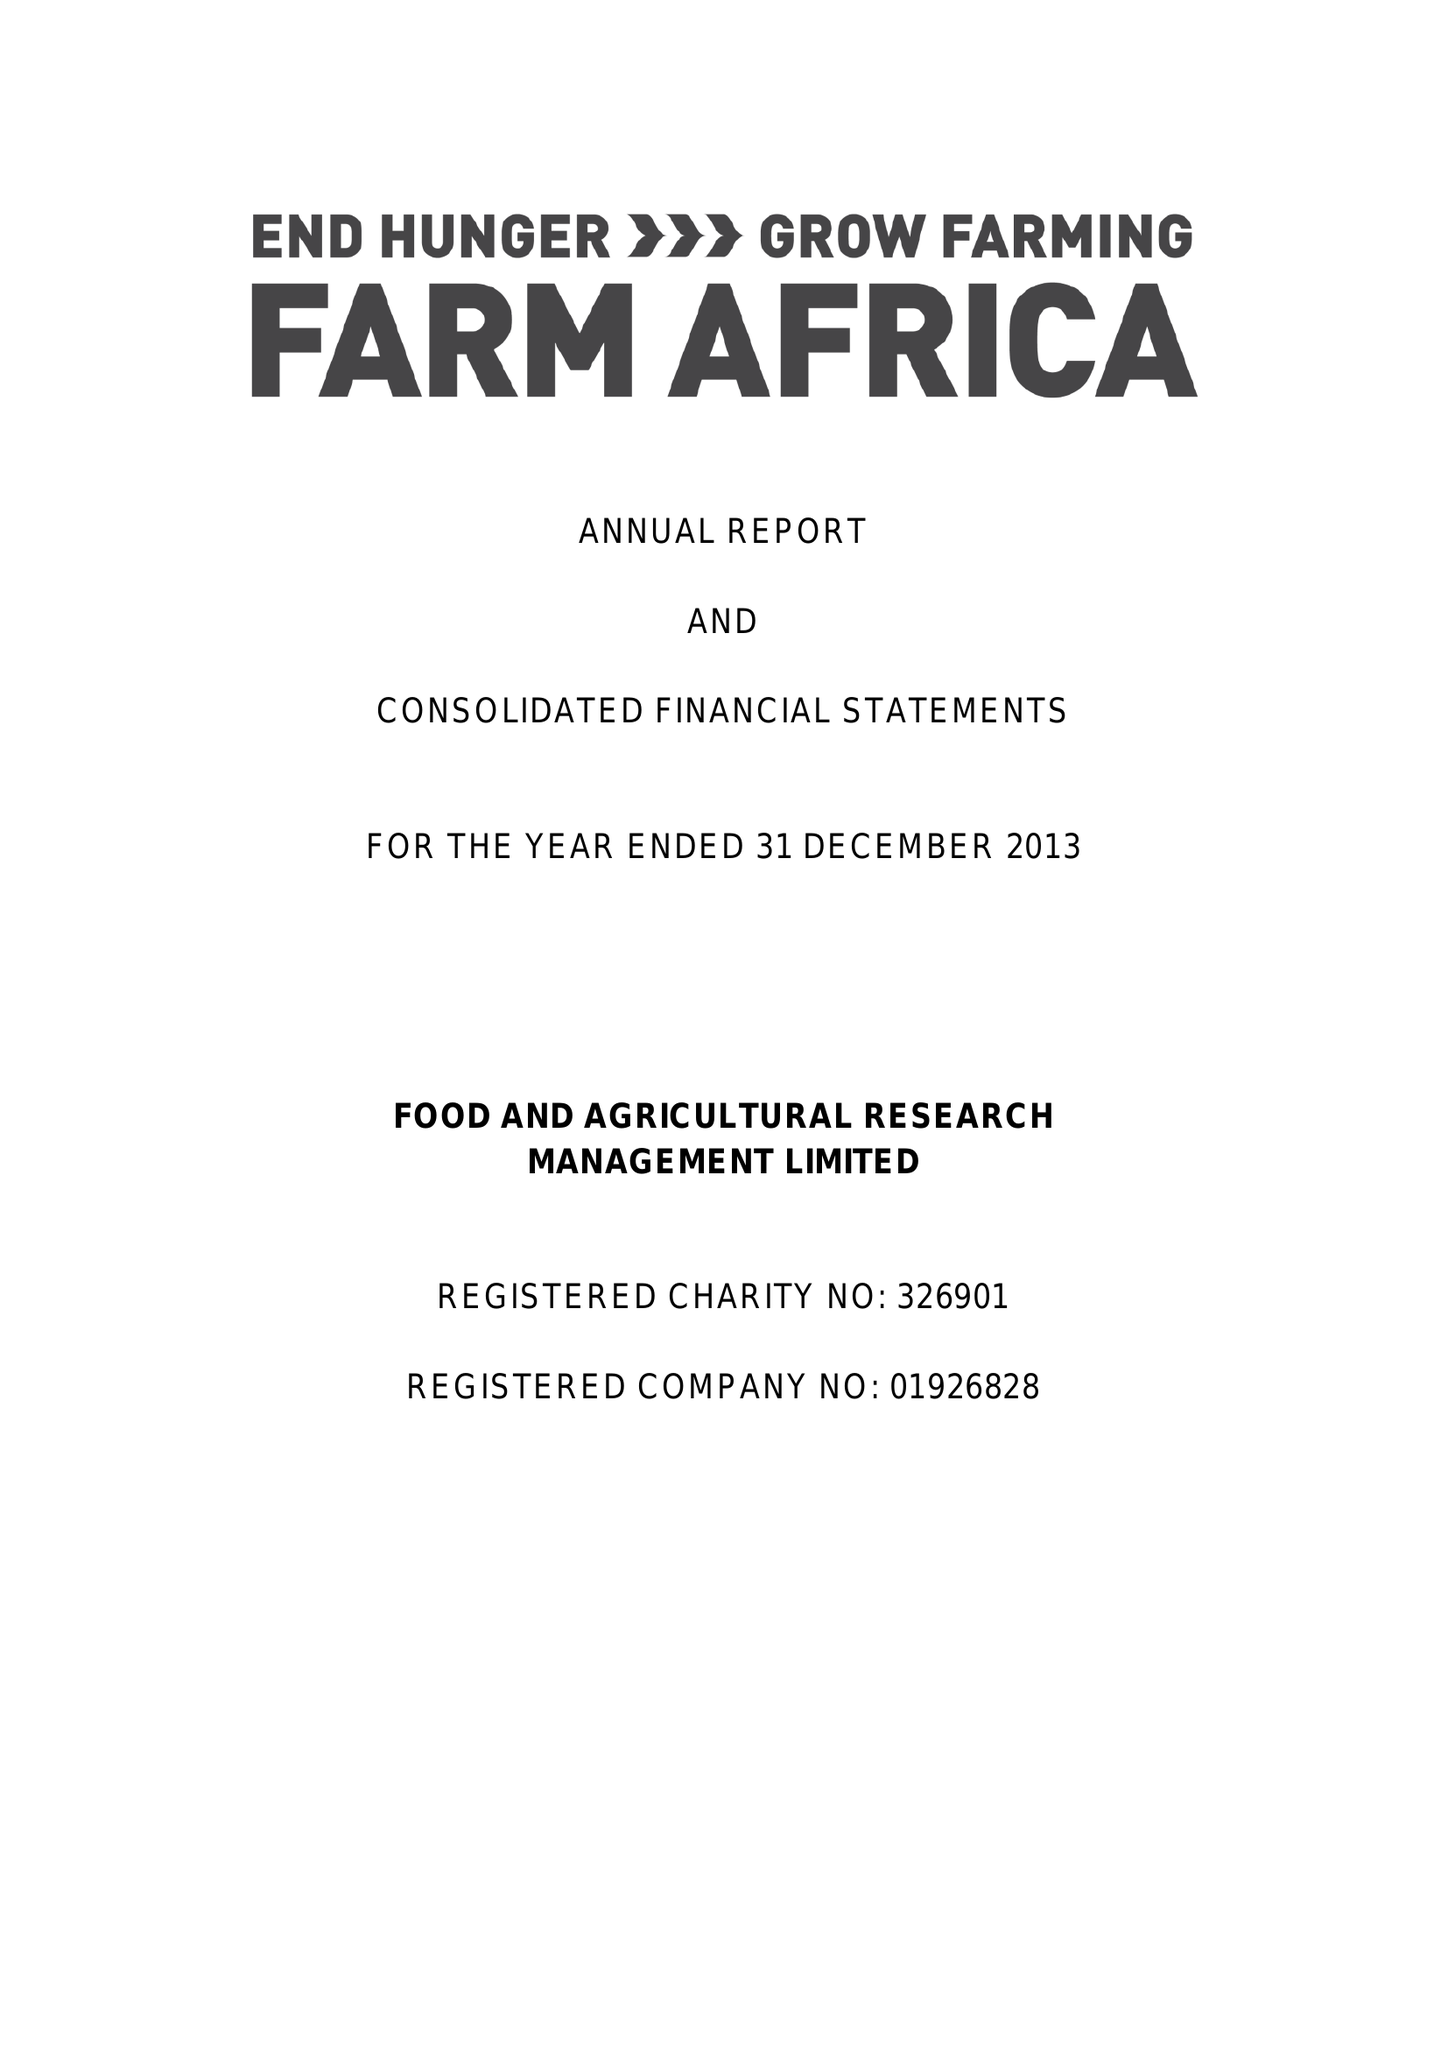What is the value for the report_date?
Answer the question using a single word or phrase. 2013-12-31 